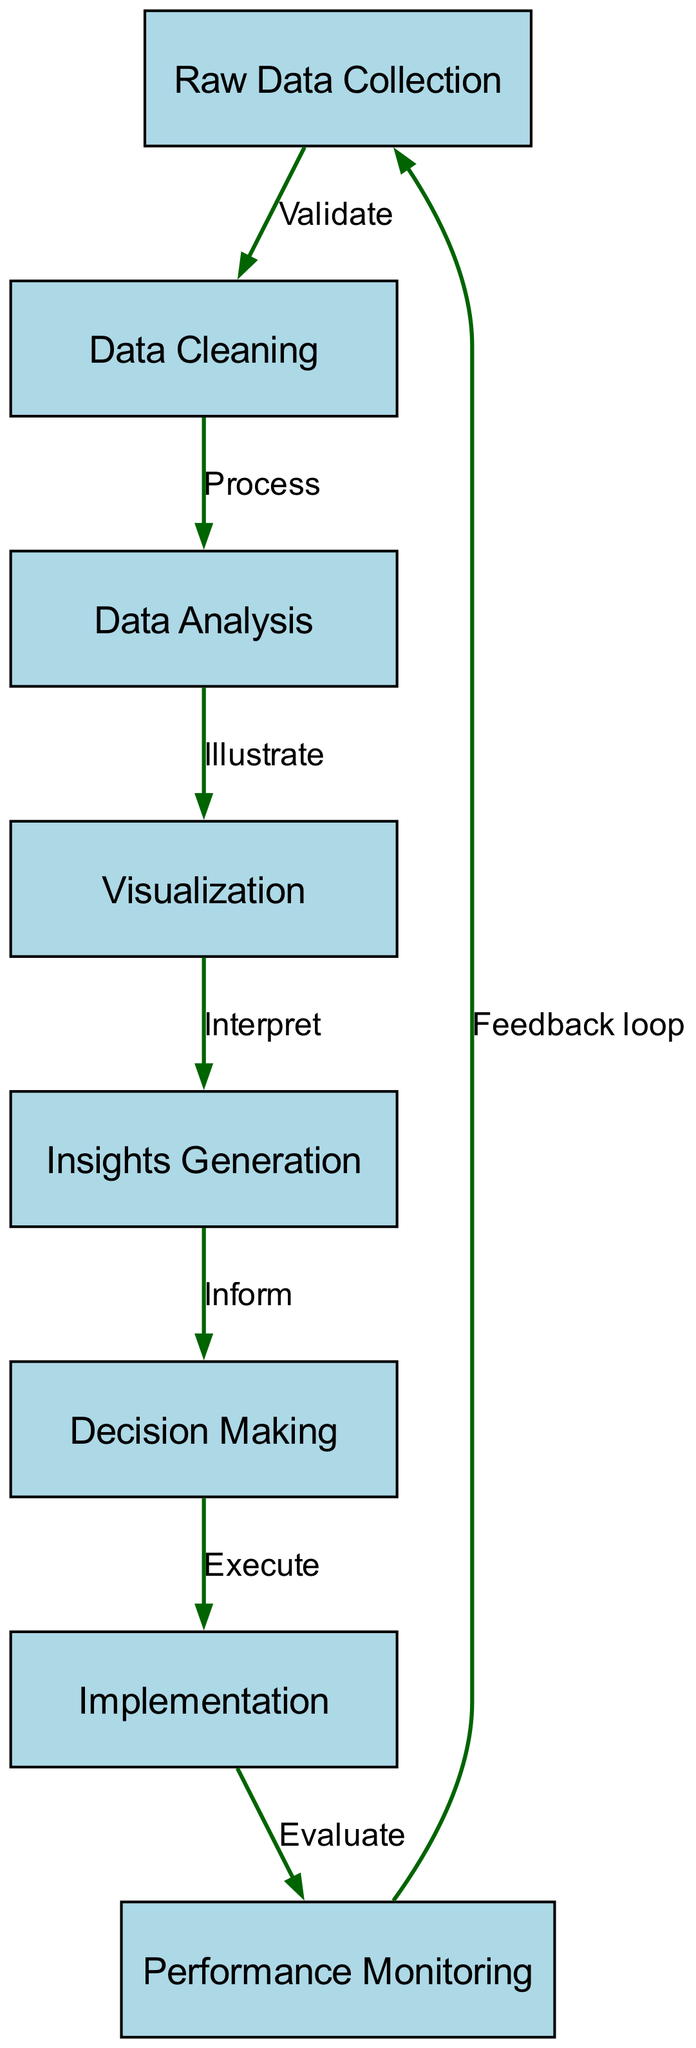What is the first step in the diagram? The first step in the diagram is "Raw Data Collection," which is indicated as the starting node from which other processes flow.
Answer: Raw Data Collection How many nodes are present in the diagram? By counting the nodes listed, we identify a total of eight distinct nodes representing different stages in the data-driven decision-making process.
Answer: 8 What is the relationship between "Data Cleaning" and "Data Analysis"? The relationship is shown by a directed edge from "Data Cleaning" to "Data Analysis" labeled "Process," indicating that data cleaning is a prerequisite for analysis.
Answer: Process Which node follows "Insights Generation"? "Decision Making" directly follows "Insights Generation" as indicated by the directed edge flowing from Insights Generation to Decision Making.
Answer: Decision Making What is the label on the edge from "Performance Monitoring" to "Raw Data Collection"? The label on the edge indicates a "Feedback loop," demonstrating that insights gained from monitoring performance inform new data collection efforts.
Answer: Feedback loop What node is the output of "Visualization"? The output of "Visualization" leads to "Insights Generation," which means that the results illustrated help generate insights for the decision-making process.
Answer: Insights Generation What is the last step in this decision-making process? The last step in the process, as shown in the diagram, is "Performance Monitoring," which indicates that performance is assessed after implementation.
Answer: Performance Monitoring What connects "Implementation" and "Performance Monitoring"? The connection is established through the edge labeled "Evaluate," showing that after implementation, an evaluation occurs that leads to performance monitoring.
Answer: Evaluate What type of graph is represented in this diagram? The diagram represents a 'Directed Graph' because it has edges that indicate a clear direction of information flow between the various nodes.
Answer: Directed Graph 